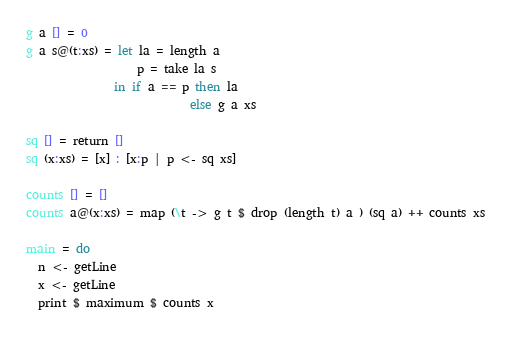Convert code to text. <code><loc_0><loc_0><loc_500><loc_500><_Haskell_>g a [] = 0
g a s@(t:xs) = let la = length a
                   p = take la s
               in if a == p then la
                            else g a xs

sq [] = return []
sq (x:xs) = [x] : [x:p | p <- sq xs]

counts [] = []
counts a@(x:xs) = map (\t -> g t $ drop (length t) a ) (sq a) ++ counts xs

main = do
  n <- getLine
  x <- getLine
  print $ maximum $ counts x</code> 